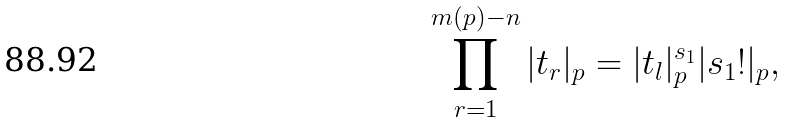<formula> <loc_0><loc_0><loc_500><loc_500>\prod ^ { m ( p ) - n } _ { r = 1 } | t _ { r } | _ { p } = | t _ { l } | ^ { s _ { 1 } } _ { p } | s _ { 1 } ! | _ { p } ,</formula> 